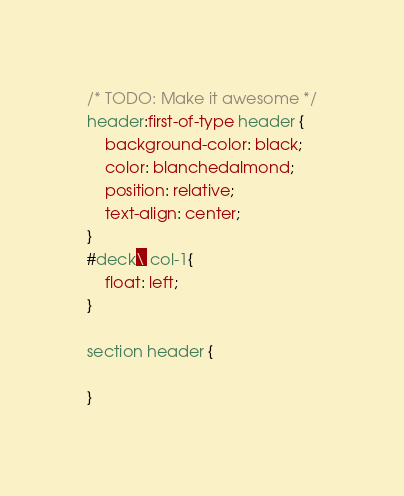<code> <loc_0><loc_0><loc_500><loc_500><_CSS_>/* TODO: Make it awesome */
header:first-of-type header {
    background-color: black;
    color: blanchedalmond;
    position: relative;
    text-align: center;
}
#deck\ col-1{
    float: left;
}

section header {

}</code> 